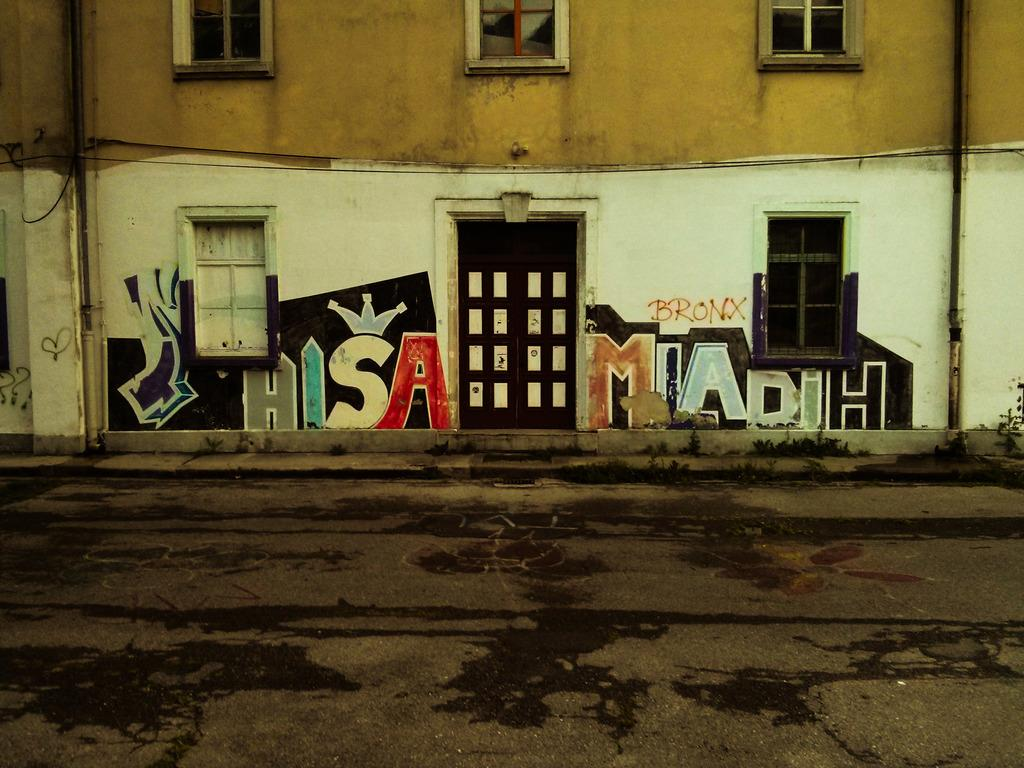What is the main structure in the picture? There is a building in the picture. What is connected to the building? A pipe is attached to the building. What is painted on the building? There is a painting of names on the building. How can people enter or exit the building? There are doors on the building. How can light enter the building? There are windows on the building. What type of fowl can be seen resting in the shade near the building? There is no fowl present in the image, and therefore no such activity can be observed. 